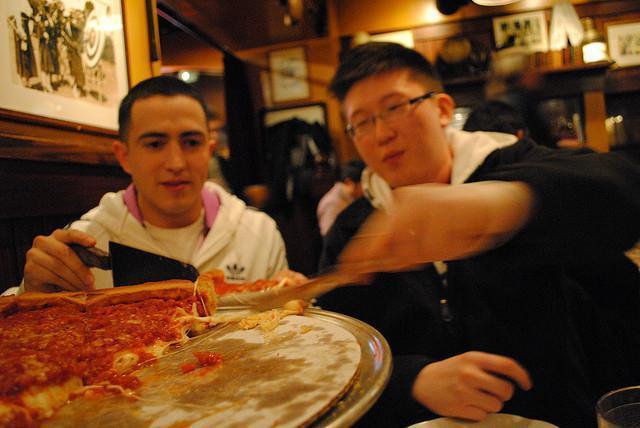How many slices are taken from the pizza?
Give a very brief answer. 4. How many people can be seen?
Give a very brief answer. 4. 